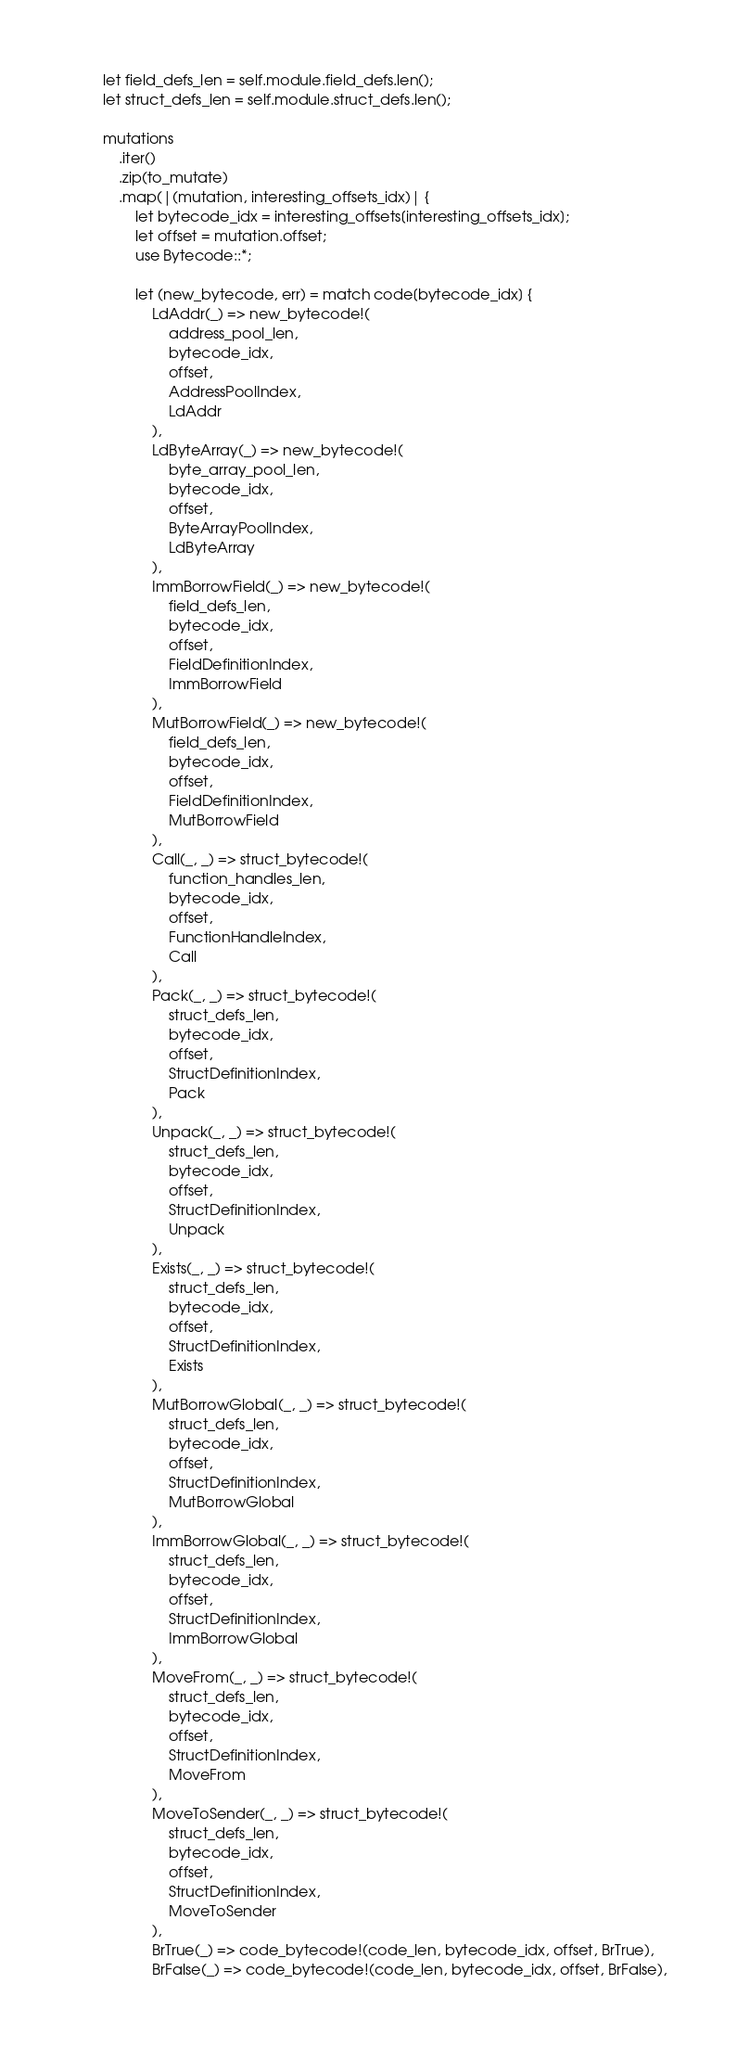<code> <loc_0><loc_0><loc_500><loc_500><_Rust_>        let field_defs_len = self.module.field_defs.len();
        let struct_defs_len = self.module.struct_defs.len();

        mutations
            .iter()
            .zip(to_mutate)
            .map(|(mutation, interesting_offsets_idx)| {
                let bytecode_idx = interesting_offsets[interesting_offsets_idx];
                let offset = mutation.offset;
                use Bytecode::*;

                let (new_bytecode, err) = match code[bytecode_idx] {
                    LdAddr(_) => new_bytecode!(
                        address_pool_len,
                        bytecode_idx,
                        offset,
                        AddressPoolIndex,
                        LdAddr
                    ),
                    LdByteArray(_) => new_bytecode!(
                        byte_array_pool_len,
                        bytecode_idx,
                        offset,
                        ByteArrayPoolIndex,
                        LdByteArray
                    ),
                    ImmBorrowField(_) => new_bytecode!(
                        field_defs_len,
                        bytecode_idx,
                        offset,
                        FieldDefinitionIndex,
                        ImmBorrowField
                    ),
                    MutBorrowField(_) => new_bytecode!(
                        field_defs_len,
                        bytecode_idx,
                        offset,
                        FieldDefinitionIndex,
                        MutBorrowField
                    ),
                    Call(_, _) => struct_bytecode!(
                        function_handles_len,
                        bytecode_idx,
                        offset,
                        FunctionHandleIndex,
                        Call
                    ),
                    Pack(_, _) => struct_bytecode!(
                        struct_defs_len,
                        bytecode_idx,
                        offset,
                        StructDefinitionIndex,
                        Pack
                    ),
                    Unpack(_, _) => struct_bytecode!(
                        struct_defs_len,
                        bytecode_idx,
                        offset,
                        StructDefinitionIndex,
                        Unpack
                    ),
                    Exists(_, _) => struct_bytecode!(
                        struct_defs_len,
                        bytecode_idx,
                        offset,
                        StructDefinitionIndex,
                        Exists
                    ),
                    MutBorrowGlobal(_, _) => struct_bytecode!(
                        struct_defs_len,
                        bytecode_idx,
                        offset,
                        StructDefinitionIndex,
                        MutBorrowGlobal
                    ),
                    ImmBorrowGlobal(_, _) => struct_bytecode!(
                        struct_defs_len,
                        bytecode_idx,
                        offset,
                        StructDefinitionIndex,
                        ImmBorrowGlobal
                    ),
                    MoveFrom(_, _) => struct_bytecode!(
                        struct_defs_len,
                        bytecode_idx,
                        offset,
                        StructDefinitionIndex,
                        MoveFrom
                    ),
                    MoveToSender(_, _) => struct_bytecode!(
                        struct_defs_len,
                        bytecode_idx,
                        offset,
                        StructDefinitionIndex,
                        MoveToSender
                    ),
                    BrTrue(_) => code_bytecode!(code_len, bytecode_idx, offset, BrTrue),
                    BrFalse(_) => code_bytecode!(code_len, bytecode_idx, offset, BrFalse),</code> 